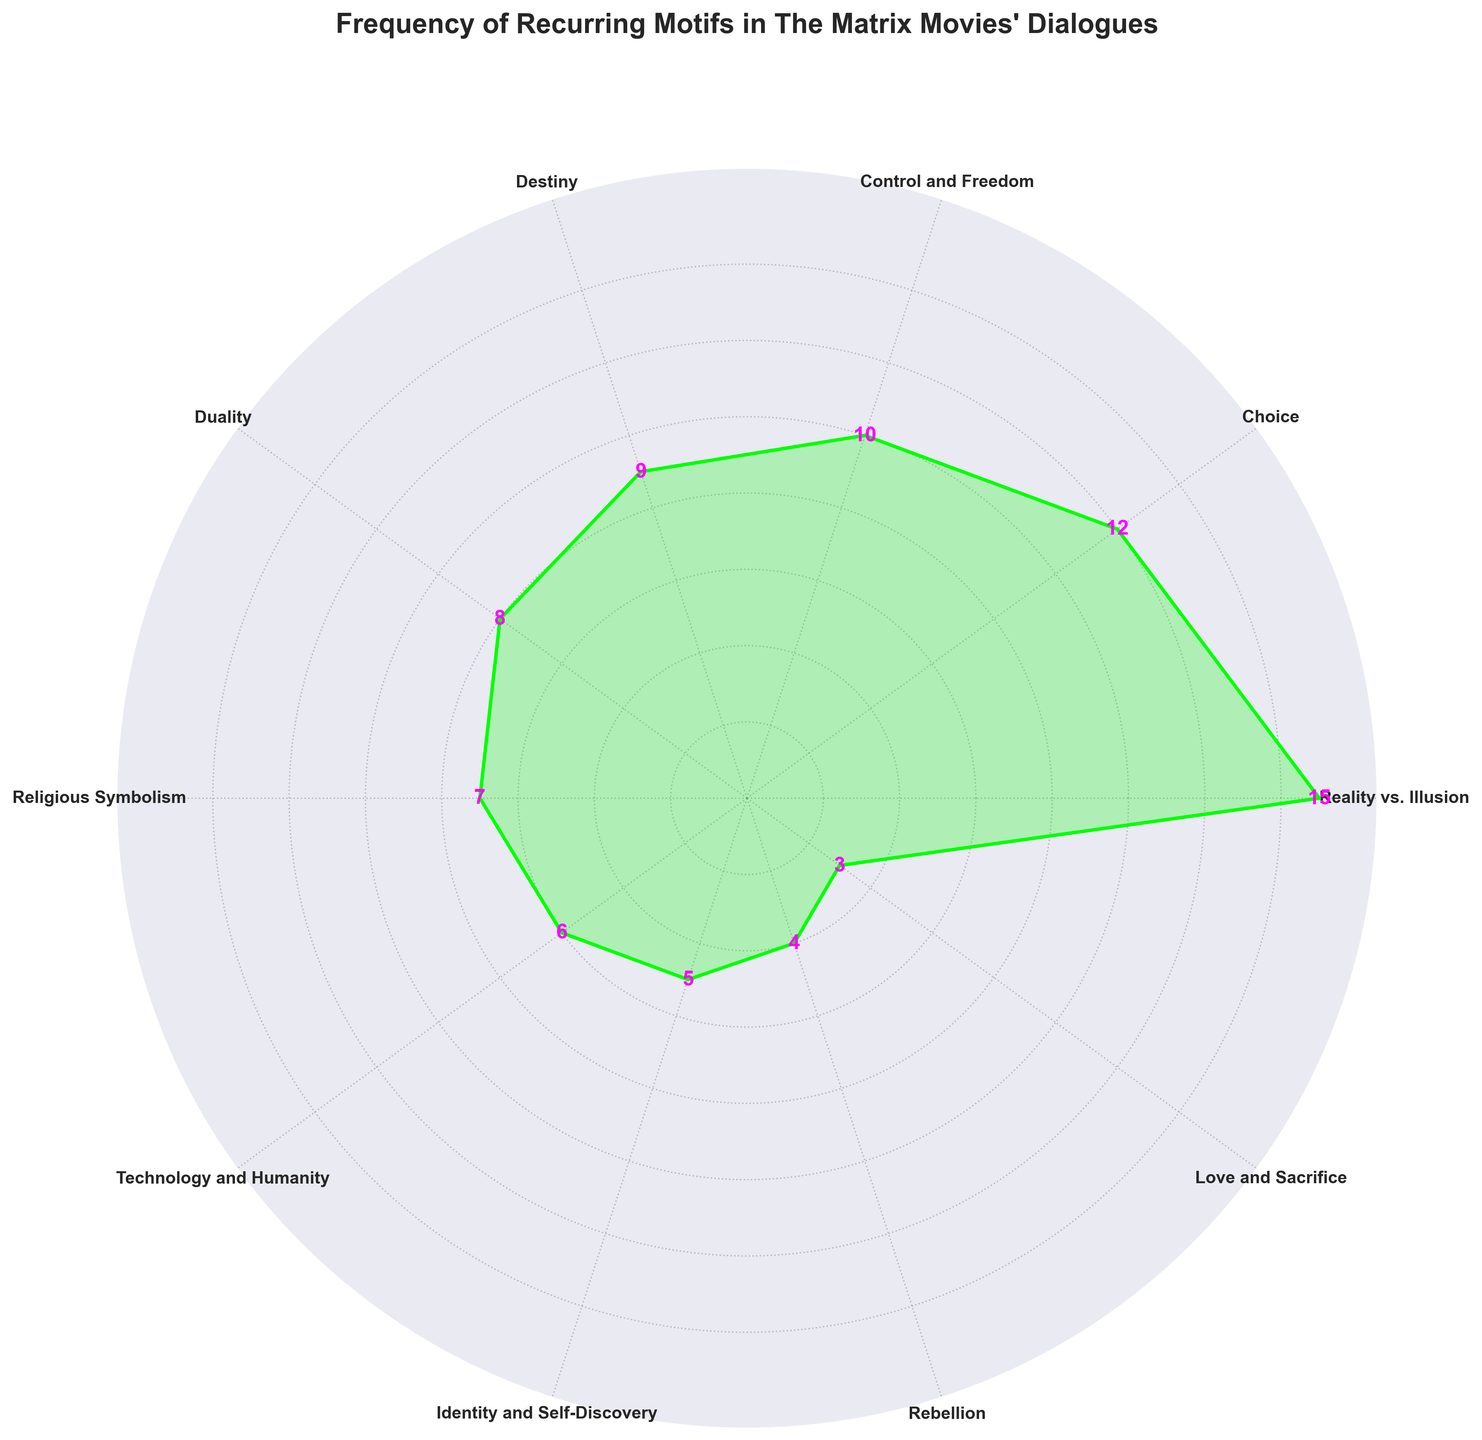What's the title of the plot? The title is usually located at the top of the plot. In this case, it is "Frequency of Recurring Motifs in The Matrix Movies' Dialogues"
Answer: Frequency of Recurring Motifs in The Matrix Movies' Dialogues How many motifs are represented in the rose chart? The number of motifs can be counted from the labels around the circular axis. There are 10 motifs in the plot.
Answer: 10 Which motif has the highest frequency? By comparing the length and position of the segments, "Reality vs. Illusion" has the longest segment indicating the highest frequency, which is 15.
Answer: Reality vs. Illusion What is the frequency of the motif "Control and Freedom"? Locate the segment labeled "Control and Freedom" and read the value at the top of the segment, which is 10.
Answer: 10 How many motifs have a frequency of 5 or less? Identify each segment with a frequency of 5 or less: "Identity and Self-Discovery", "Rebellion", and "Love and Sacrifice". There are 3 such motifs.
Answer: 3 Which motifs have a frequency less than “Choice” but more than “Duality”? Comparing the segments, "Control and Freedom" (10) and "Destiny" (9) are the only motifs with frequencies between “Choice” (12) and “Duality” (8).
Answer: Control and Freedom and Destiny What is the total frequency of all motifs combined? Sum all the frequencies: 15 + 12 + 10 + 9 + 8 + 7 + 6 + 5 + 4 + 3 = 79.
Answer: 79 Which motif has the smallest frequency? By checking the shortest segment, "Love and Sacrifice" has the smallest frequency, which is 3.
Answer: Love and Sacrifice How do the frequencies of "Religious Symbolism" and "Technology and Humanity" compare? "Religious Symbolism" has a frequency of 7 and "Technology and Humanity" has a frequency of 6. Therefore, "Religious Symbolism" has a higher frequency by 1.
Answer: Religious Symbolism is higher by 1 What is the average frequency of the motifs? Calculate the average by dividing the total frequency (79) by the number of motifs (10): 79/10 = 7.9.
Answer: 7.9 